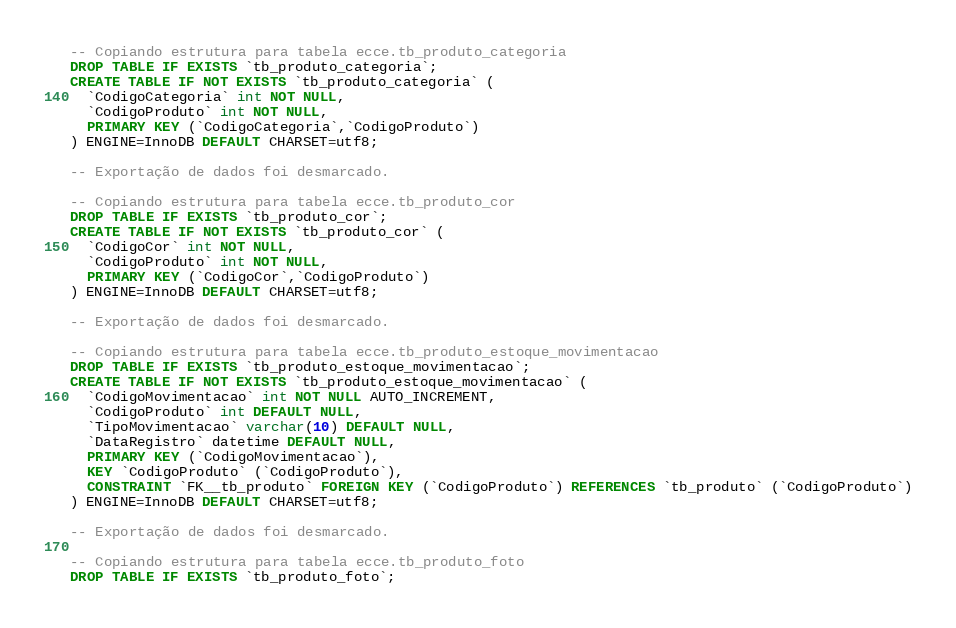Convert code to text. <code><loc_0><loc_0><loc_500><loc_500><_SQL_>
-- Copiando estrutura para tabela ecce.tb_produto_categoria
DROP TABLE IF EXISTS `tb_produto_categoria`;
CREATE TABLE IF NOT EXISTS `tb_produto_categoria` (
  `CodigoCategoria` int NOT NULL,
  `CodigoProduto` int NOT NULL,
  PRIMARY KEY (`CodigoCategoria`,`CodigoProduto`)
) ENGINE=InnoDB DEFAULT CHARSET=utf8;

-- Exportação de dados foi desmarcado.

-- Copiando estrutura para tabela ecce.tb_produto_cor
DROP TABLE IF EXISTS `tb_produto_cor`;
CREATE TABLE IF NOT EXISTS `tb_produto_cor` (
  `CodigoCor` int NOT NULL,
  `CodigoProduto` int NOT NULL,
  PRIMARY KEY (`CodigoCor`,`CodigoProduto`)
) ENGINE=InnoDB DEFAULT CHARSET=utf8;

-- Exportação de dados foi desmarcado.

-- Copiando estrutura para tabela ecce.tb_produto_estoque_movimentacao
DROP TABLE IF EXISTS `tb_produto_estoque_movimentacao`;
CREATE TABLE IF NOT EXISTS `tb_produto_estoque_movimentacao` (
  `CodigoMovimentacao` int NOT NULL AUTO_INCREMENT,
  `CodigoProduto` int DEFAULT NULL,
  `TipoMovimentacao` varchar(10) DEFAULT NULL,
  `DataRegistro` datetime DEFAULT NULL,
  PRIMARY KEY (`CodigoMovimentacao`),
  KEY `CodigoProduto` (`CodigoProduto`),
  CONSTRAINT `FK__tb_produto` FOREIGN KEY (`CodigoProduto`) REFERENCES `tb_produto` (`CodigoProduto`)
) ENGINE=InnoDB DEFAULT CHARSET=utf8;

-- Exportação de dados foi desmarcado.

-- Copiando estrutura para tabela ecce.tb_produto_foto
DROP TABLE IF EXISTS `tb_produto_foto`;</code> 